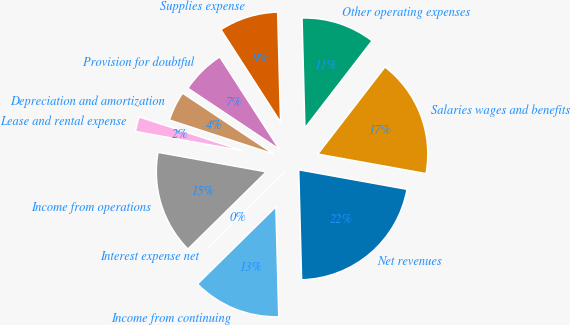Convert chart to OTSL. <chart><loc_0><loc_0><loc_500><loc_500><pie_chart><fcel>Net revenues<fcel>Salaries wages and benefits<fcel>Other operating expenses<fcel>Supplies expense<fcel>Provision for doubtful<fcel>Depreciation and amortization<fcel>Lease and rental expense<fcel>Income from operations<fcel>Interest expense net<fcel>Income from continuing<nl><fcel>21.74%<fcel>17.39%<fcel>10.87%<fcel>8.7%<fcel>6.52%<fcel>4.35%<fcel>2.18%<fcel>15.22%<fcel>0.0%<fcel>13.04%<nl></chart> 